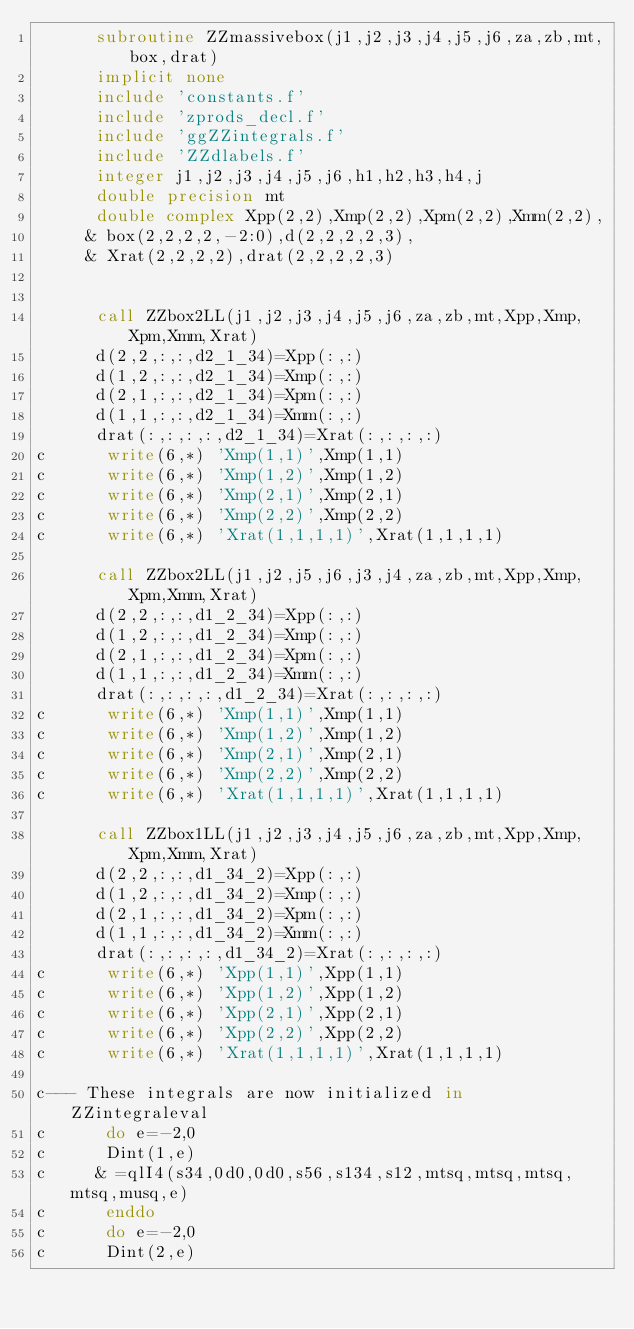Convert code to text. <code><loc_0><loc_0><loc_500><loc_500><_FORTRAN_>      subroutine ZZmassivebox(j1,j2,j3,j4,j5,j6,za,zb,mt,box,drat)
      implicit none
      include 'constants.f'
      include 'zprods_decl.f'
      include 'ggZZintegrals.f'
      include 'ZZdlabels.f'
      integer j1,j2,j3,j4,j5,j6,h1,h2,h3,h4,j
      double precision mt
      double complex Xpp(2,2),Xmp(2,2),Xpm(2,2),Xmm(2,2),
     & box(2,2,2,2,-2:0),d(2,2,2,2,3),
     & Xrat(2,2,2,2),drat(2,2,2,2,3)
      

      call ZZbox2LL(j1,j2,j3,j4,j5,j6,za,zb,mt,Xpp,Xmp,Xpm,Xmm,Xrat)
      d(2,2,:,:,d2_1_34)=Xpp(:,:)
      d(1,2,:,:,d2_1_34)=Xmp(:,:)
      d(2,1,:,:,d2_1_34)=Xpm(:,:)
      d(1,1,:,:,d2_1_34)=Xmm(:,:)
      drat(:,:,:,:,d2_1_34)=Xrat(:,:,:,:)
c      write(6,*) 'Xmp(1,1)',Xmp(1,1)
c      write(6,*) 'Xmp(1,2)',Xmp(1,2)
c      write(6,*) 'Xmp(2,1)',Xmp(2,1)
c      write(6,*) 'Xmp(2,2)',Xmp(2,2)
c      write(6,*) 'Xrat(1,1,1,1)',Xrat(1,1,1,1)
      
      call ZZbox2LL(j1,j2,j5,j6,j3,j4,za,zb,mt,Xpp,Xmp,Xpm,Xmm,Xrat)
      d(2,2,:,:,d1_2_34)=Xpp(:,:)
      d(1,2,:,:,d1_2_34)=Xmp(:,:)
      d(2,1,:,:,d1_2_34)=Xpm(:,:)
      d(1,1,:,:,d1_2_34)=Xmm(:,:)
      drat(:,:,:,:,d1_2_34)=Xrat(:,:,:,:)
c      write(6,*) 'Xmp(1,1)',Xmp(1,1)
c      write(6,*) 'Xmp(1,2)',Xmp(1,2)
c      write(6,*) 'Xmp(2,1)',Xmp(2,1)
c      write(6,*) 'Xmp(2,2)',Xmp(2,2)
c      write(6,*) 'Xrat(1,1,1,1)',Xrat(1,1,1,1)

      call ZZbox1LL(j1,j2,j3,j4,j5,j6,za,zb,mt,Xpp,Xmp,Xpm,Xmm,Xrat)
      d(2,2,:,:,d1_34_2)=Xpp(:,:)
      d(1,2,:,:,d1_34_2)=Xmp(:,:)
      d(2,1,:,:,d1_34_2)=Xpm(:,:)
      d(1,1,:,:,d1_34_2)=Xmm(:,:)
      drat(:,:,:,:,d1_34_2)=Xrat(:,:,:,:)
c      write(6,*) 'Xpp(1,1)',Xpp(1,1)
c      write(6,*) 'Xpp(1,2)',Xpp(1,2)
c      write(6,*) 'Xpp(2,1)',Xpp(2,1)
c      write(6,*) 'Xpp(2,2)',Xpp(2,2)
c      write(6,*) 'Xrat(1,1,1,1)',Xrat(1,1,1,1)

c--- These integrals are now initialized in ZZintegraleval      
c      do e=-2,0
c      Dint(1,e)
c     & =qlI4(s34,0d0,0d0,s56,s134,s12,mtsq,mtsq,mtsq,mtsq,musq,e)
c      enddo
c      do e=-2,0
c      Dint(2,e)</code> 